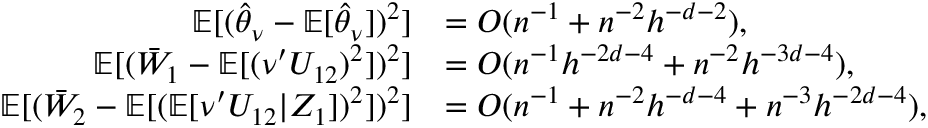Convert formula to latex. <formula><loc_0><loc_0><loc_500><loc_500>\begin{array} { r l } { \mathbb { E } [ ( \widehat { \theta } _ { \nu } - \mathbb { E } [ \widehat { \theta } _ { \nu } ] ) ^ { 2 } ] } & { = O ( n ^ { - 1 } + n ^ { - 2 } h ^ { - d - 2 } ) , } \\ { \mathbb { E } [ ( \bar { W } _ { 1 } - \mathbb { E } [ ( \nu ^ { \prime } U _ { 1 2 } ) ^ { 2 } ] ) ^ { 2 } ] } & { = O ( n ^ { - 1 } h ^ { - 2 d - 4 } + n ^ { - 2 } h ^ { - 3 d - 4 } ) , } \\ { \mathbb { E } [ ( \bar { W } _ { 2 } - \mathbb { E } [ ( \mathbb { E } [ \nu ^ { \prime } U _ { 1 2 } | Z _ { 1 } ] ) ^ { 2 } ] ) ^ { 2 } ] } & { = O ( n ^ { - 1 } + n ^ { - 2 } h ^ { - d - 4 } + n ^ { - 3 } h ^ { - 2 d - 4 } ) , } \end{array}</formula> 